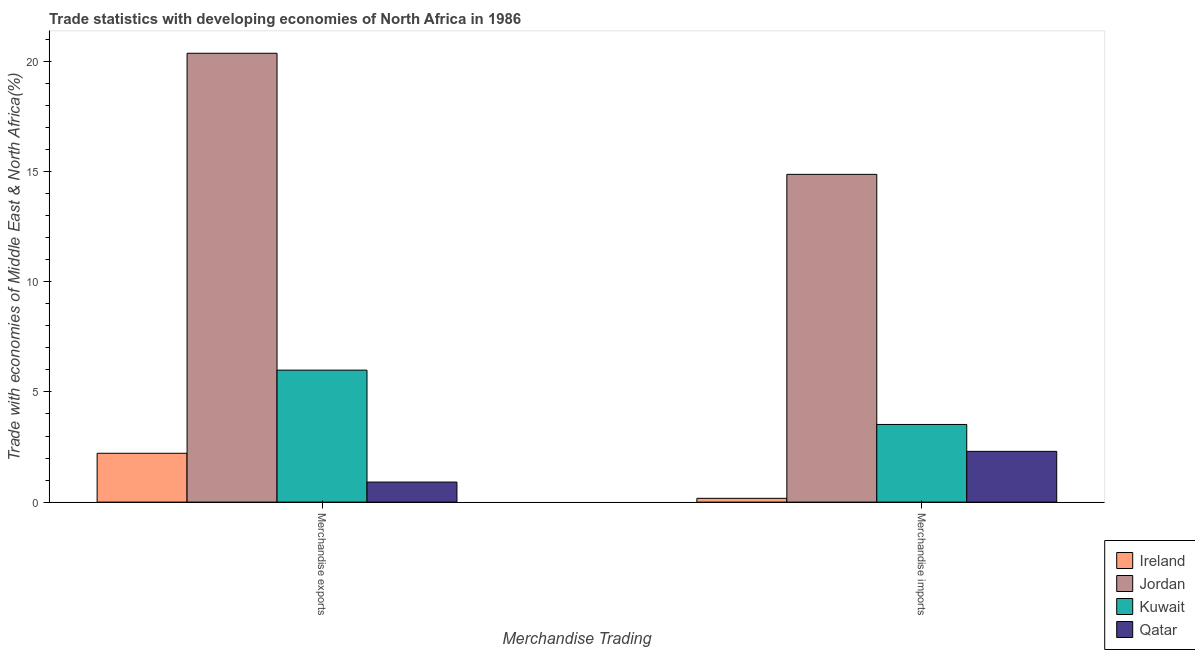How many groups of bars are there?
Your answer should be very brief. 2. Are the number of bars per tick equal to the number of legend labels?
Provide a short and direct response. Yes. How many bars are there on the 2nd tick from the left?
Offer a very short reply. 4. How many bars are there on the 1st tick from the right?
Your response must be concise. 4. What is the label of the 2nd group of bars from the left?
Ensure brevity in your answer.  Merchandise imports. What is the merchandise imports in Kuwait?
Your answer should be compact. 3.52. Across all countries, what is the maximum merchandise imports?
Provide a succinct answer. 14.88. Across all countries, what is the minimum merchandise imports?
Provide a short and direct response. 0.17. In which country was the merchandise imports maximum?
Ensure brevity in your answer.  Jordan. In which country was the merchandise imports minimum?
Provide a short and direct response. Ireland. What is the total merchandise exports in the graph?
Provide a succinct answer. 29.49. What is the difference between the merchandise exports in Kuwait and that in Ireland?
Your response must be concise. 3.77. What is the difference between the merchandise imports in Kuwait and the merchandise exports in Qatar?
Give a very brief answer. 2.61. What is the average merchandise imports per country?
Your answer should be compact. 5.22. What is the difference between the merchandise exports and merchandise imports in Kuwait?
Your answer should be very brief. 2.47. In how many countries, is the merchandise exports greater than 17 %?
Your response must be concise. 1. What is the ratio of the merchandise exports in Jordan to that in Kuwait?
Your response must be concise. 3.4. Is the merchandise imports in Kuwait less than that in Jordan?
Your answer should be very brief. Yes. What does the 2nd bar from the left in Merchandise exports represents?
Keep it short and to the point. Jordan. What does the 4th bar from the right in Merchandise exports represents?
Give a very brief answer. Ireland. How many bars are there?
Ensure brevity in your answer.  8. Does the graph contain any zero values?
Your answer should be very brief. No. Where does the legend appear in the graph?
Your answer should be compact. Bottom right. How many legend labels are there?
Offer a very short reply. 4. How are the legend labels stacked?
Offer a very short reply. Vertical. What is the title of the graph?
Keep it short and to the point. Trade statistics with developing economies of North Africa in 1986. What is the label or title of the X-axis?
Offer a terse response. Merchandise Trading. What is the label or title of the Y-axis?
Keep it short and to the point. Trade with economies of Middle East & North Africa(%). What is the Trade with economies of Middle East & North Africa(%) of Ireland in Merchandise exports?
Provide a succinct answer. 2.22. What is the Trade with economies of Middle East & North Africa(%) of Jordan in Merchandise exports?
Give a very brief answer. 20.37. What is the Trade with economies of Middle East & North Africa(%) in Kuwait in Merchandise exports?
Offer a terse response. 5.99. What is the Trade with economies of Middle East & North Africa(%) in Qatar in Merchandise exports?
Make the answer very short. 0.91. What is the Trade with economies of Middle East & North Africa(%) of Ireland in Merchandise imports?
Make the answer very short. 0.17. What is the Trade with economies of Middle East & North Africa(%) in Jordan in Merchandise imports?
Provide a short and direct response. 14.88. What is the Trade with economies of Middle East & North Africa(%) of Kuwait in Merchandise imports?
Your answer should be very brief. 3.52. What is the Trade with economies of Middle East & North Africa(%) in Qatar in Merchandise imports?
Ensure brevity in your answer.  2.3. Across all Merchandise Trading, what is the maximum Trade with economies of Middle East & North Africa(%) in Ireland?
Your answer should be very brief. 2.22. Across all Merchandise Trading, what is the maximum Trade with economies of Middle East & North Africa(%) in Jordan?
Offer a terse response. 20.37. Across all Merchandise Trading, what is the maximum Trade with economies of Middle East & North Africa(%) of Kuwait?
Give a very brief answer. 5.99. Across all Merchandise Trading, what is the maximum Trade with economies of Middle East & North Africa(%) of Qatar?
Offer a terse response. 2.3. Across all Merchandise Trading, what is the minimum Trade with economies of Middle East & North Africa(%) in Ireland?
Your response must be concise. 0.17. Across all Merchandise Trading, what is the minimum Trade with economies of Middle East & North Africa(%) of Jordan?
Make the answer very short. 14.88. Across all Merchandise Trading, what is the minimum Trade with economies of Middle East & North Africa(%) in Kuwait?
Give a very brief answer. 3.52. Across all Merchandise Trading, what is the minimum Trade with economies of Middle East & North Africa(%) in Qatar?
Ensure brevity in your answer.  0.91. What is the total Trade with economies of Middle East & North Africa(%) of Ireland in the graph?
Give a very brief answer. 2.39. What is the total Trade with economies of Middle East & North Africa(%) of Jordan in the graph?
Offer a terse response. 35.25. What is the total Trade with economies of Middle East & North Africa(%) in Kuwait in the graph?
Make the answer very short. 9.52. What is the total Trade with economies of Middle East & North Africa(%) of Qatar in the graph?
Your answer should be very brief. 3.22. What is the difference between the Trade with economies of Middle East & North Africa(%) in Ireland in Merchandise exports and that in Merchandise imports?
Make the answer very short. 2.05. What is the difference between the Trade with economies of Middle East & North Africa(%) of Jordan in Merchandise exports and that in Merchandise imports?
Your response must be concise. 5.5. What is the difference between the Trade with economies of Middle East & North Africa(%) in Kuwait in Merchandise exports and that in Merchandise imports?
Provide a short and direct response. 2.47. What is the difference between the Trade with economies of Middle East & North Africa(%) in Qatar in Merchandise exports and that in Merchandise imports?
Offer a terse response. -1.39. What is the difference between the Trade with economies of Middle East & North Africa(%) in Ireland in Merchandise exports and the Trade with economies of Middle East & North Africa(%) in Jordan in Merchandise imports?
Give a very brief answer. -12.66. What is the difference between the Trade with economies of Middle East & North Africa(%) of Ireland in Merchandise exports and the Trade with economies of Middle East & North Africa(%) of Kuwait in Merchandise imports?
Give a very brief answer. -1.31. What is the difference between the Trade with economies of Middle East & North Africa(%) in Ireland in Merchandise exports and the Trade with economies of Middle East & North Africa(%) in Qatar in Merchandise imports?
Offer a terse response. -0.09. What is the difference between the Trade with economies of Middle East & North Africa(%) in Jordan in Merchandise exports and the Trade with economies of Middle East & North Africa(%) in Kuwait in Merchandise imports?
Keep it short and to the point. 16.85. What is the difference between the Trade with economies of Middle East & North Africa(%) in Jordan in Merchandise exports and the Trade with economies of Middle East & North Africa(%) in Qatar in Merchandise imports?
Offer a terse response. 18.07. What is the difference between the Trade with economies of Middle East & North Africa(%) of Kuwait in Merchandise exports and the Trade with economies of Middle East & North Africa(%) of Qatar in Merchandise imports?
Ensure brevity in your answer.  3.69. What is the average Trade with economies of Middle East & North Africa(%) of Ireland per Merchandise Trading?
Your response must be concise. 1.19. What is the average Trade with economies of Middle East & North Africa(%) of Jordan per Merchandise Trading?
Keep it short and to the point. 17.62. What is the average Trade with economies of Middle East & North Africa(%) of Kuwait per Merchandise Trading?
Ensure brevity in your answer.  4.76. What is the average Trade with economies of Middle East & North Africa(%) in Qatar per Merchandise Trading?
Your answer should be compact. 1.61. What is the difference between the Trade with economies of Middle East & North Africa(%) in Ireland and Trade with economies of Middle East & North Africa(%) in Jordan in Merchandise exports?
Give a very brief answer. -18.15. What is the difference between the Trade with economies of Middle East & North Africa(%) in Ireland and Trade with economies of Middle East & North Africa(%) in Kuwait in Merchandise exports?
Ensure brevity in your answer.  -3.77. What is the difference between the Trade with economies of Middle East & North Africa(%) of Ireland and Trade with economies of Middle East & North Africa(%) of Qatar in Merchandise exports?
Give a very brief answer. 1.31. What is the difference between the Trade with economies of Middle East & North Africa(%) of Jordan and Trade with economies of Middle East & North Africa(%) of Kuwait in Merchandise exports?
Your answer should be very brief. 14.38. What is the difference between the Trade with economies of Middle East & North Africa(%) of Jordan and Trade with economies of Middle East & North Africa(%) of Qatar in Merchandise exports?
Give a very brief answer. 19.46. What is the difference between the Trade with economies of Middle East & North Africa(%) in Kuwait and Trade with economies of Middle East & North Africa(%) in Qatar in Merchandise exports?
Keep it short and to the point. 5.08. What is the difference between the Trade with economies of Middle East & North Africa(%) of Ireland and Trade with economies of Middle East & North Africa(%) of Jordan in Merchandise imports?
Keep it short and to the point. -14.7. What is the difference between the Trade with economies of Middle East & North Africa(%) in Ireland and Trade with economies of Middle East & North Africa(%) in Kuwait in Merchandise imports?
Your answer should be very brief. -3.35. What is the difference between the Trade with economies of Middle East & North Africa(%) in Ireland and Trade with economies of Middle East & North Africa(%) in Qatar in Merchandise imports?
Offer a terse response. -2.13. What is the difference between the Trade with economies of Middle East & North Africa(%) in Jordan and Trade with economies of Middle East & North Africa(%) in Kuwait in Merchandise imports?
Ensure brevity in your answer.  11.35. What is the difference between the Trade with economies of Middle East & North Africa(%) of Jordan and Trade with economies of Middle East & North Africa(%) of Qatar in Merchandise imports?
Give a very brief answer. 12.57. What is the difference between the Trade with economies of Middle East & North Africa(%) of Kuwait and Trade with economies of Middle East & North Africa(%) of Qatar in Merchandise imports?
Your answer should be compact. 1.22. What is the ratio of the Trade with economies of Middle East & North Africa(%) in Ireland in Merchandise exports to that in Merchandise imports?
Provide a short and direct response. 12.86. What is the ratio of the Trade with economies of Middle East & North Africa(%) in Jordan in Merchandise exports to that in Merchandise imports?
Make the answer very short. 1.37. What is the ratio of the Trade with economies of Middle East & North Africa(%) in Kuwait in Merchandise exports to that in Merchandise imports?
Your answer should be compact. 1.7. What is the ratio of the Trade with economies of Middle East & North Africa(%) of Qatar in Merchandise exports to that in Merchandise imports?
Keep it short and to the point. 0.4. What is the difference between the highest and the second highest Trade with economies of Middle East & North Africa(%) of Ireland?
Make the answer very short. 2.05. What is the difference between the highest and the second highest Trade with economies of Middle East & North Africa(%) in Jordan?
Offer a terse response. 5.5. What is the difference between the highest and the second highest Trade with economies of Middle East & North Africa(%) of Kuwait?
Your answer should be very brief. 2.47. What is the difference between the highest and the second highest Trade with economies of Middle East & North Africa(%) of Qatar?
Keep it short and to the point. 1.39. What is the difference between the highest and the lowest Trade with economies of Middle East & North Africa(%) of Ireland?
Provide a short and direct response. 2.05. What is the difference between the highest and the lowest Trade with economies of Middle East & North Africa(%) in Jordan?
Offer a terse response. 5.5. What is the difference between the highest and the lowest Trade with economies of Middle East & North Africa(%) of Kuwait?
Provide a succinct answer. 2.47. What is the difference between the highest and the lowest Trade with economies of Middle East & North Africa(%) in Qatar?
Make the answer very short. 1.39. 